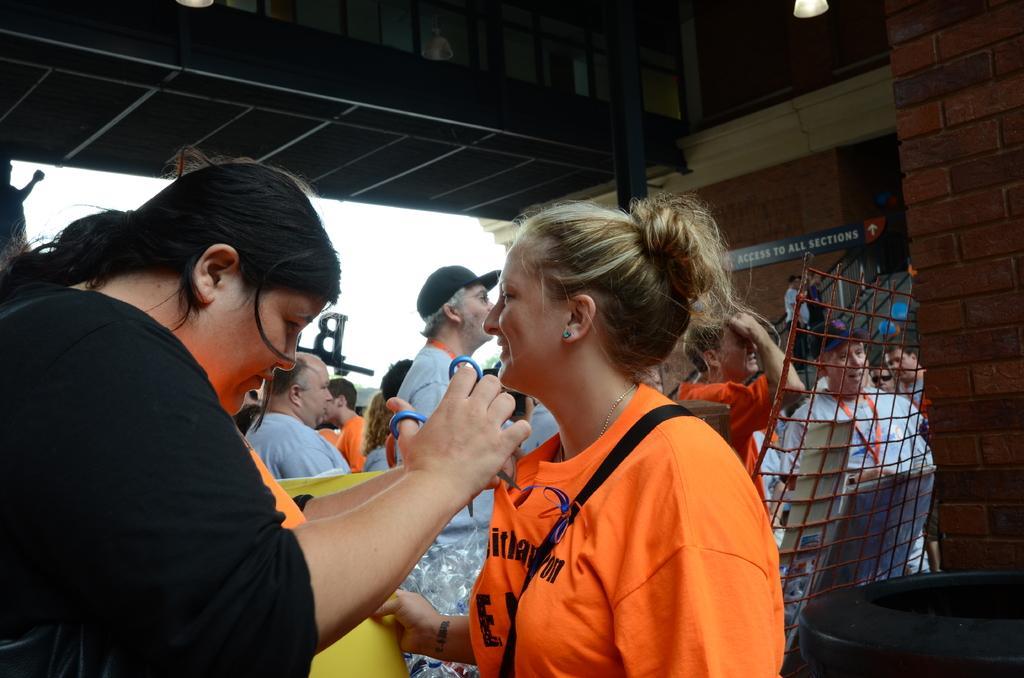How would you summarize this image in a sentence or two? In the image we can see there are many people around and they are wearing clothes. This is an ear stud, scissor, fence, pole, light, board, brick wall, cap and a white sky. 